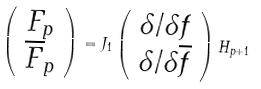<formula> <loc_0><loc_0><loc_500><loc_500>\left ( \begin{array} { c c } F _ { p } \\ { \overline { F } } _ { p } \end{array} \right ) = J _ { 1 } \left ( \begin{array} { c c } { \delta } / { \delta f } \\ \delta / { \delta { \overline { f } } } \end{array} \right ) H _ { p + 1 }</formula> 